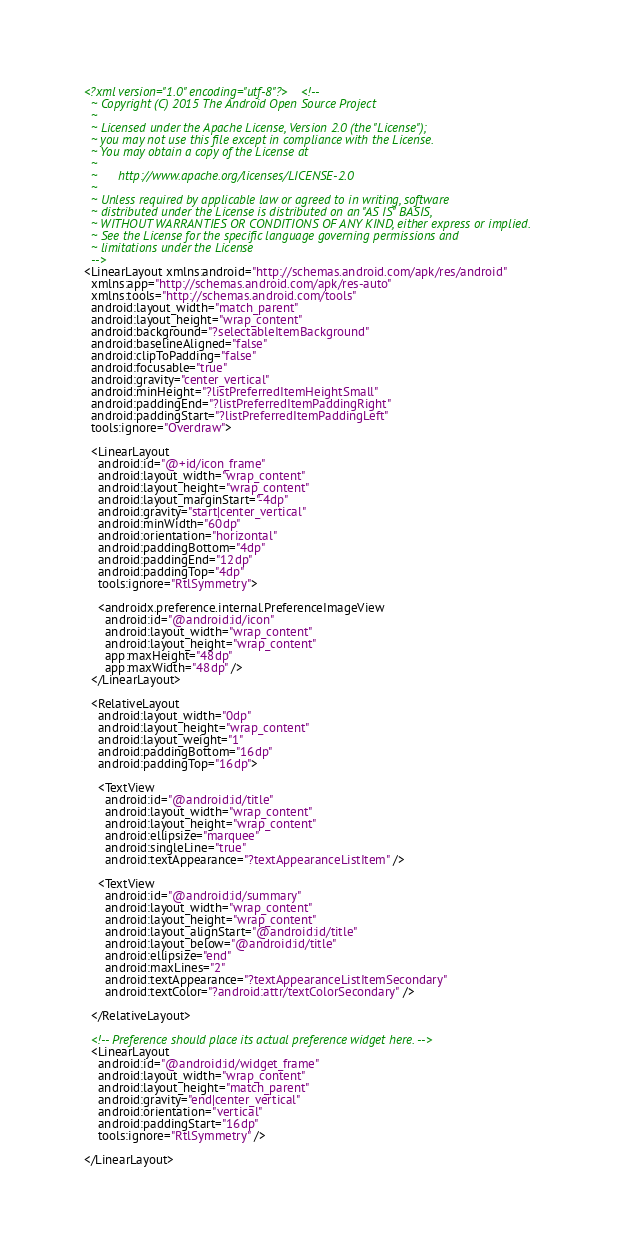<code> <loc_0><loc_0><loc_500><loc_500><_XML_><?xml version="1.0" encoding="utf-8"?><!--
  ~ Copyright (C) 2015 The Android Open Source Project
  ~
  ~ Licensed under the Apache License, Version 2.0 (the "License");
  ~ you may not use this file except in compliance with the License.
  ~ You may obtain a copy of the License at
  ~
  ~      http://www.apache.org/licenses/LICENSE-2.0
  ~
  ~ Unless required by applicable law or agreed to in writing, software
  ~ distributed under the License is distributed on an "AS IS" BASIS,
  ~ WITHOUT WARRANTIES OR CONDITIONS OF ANY KIND, either express or implied.
  ~ See the License for the specific language governing permissions and
  ~ limitations under the License
  -->
<LinearLayout xmlns:android="http://schemas.android.com/apk/res/android"
  xmlns:app="http://schemas.android.com/apk/res-auto"
  xmlns:tools="http://schemas.android.com/tools"
  android:layout_width="match_parent"
  android:layout_height="wrap_content"
  android:background="?selectableItemBackground"
  android:baselineAligned="false"
  android:clipToPadding="false"
  android:focusable="true"
  android:gravity="center_vertical"
  android:minHeight="?listPreferredItemHeightSmall"
  android:paddingEnd="?listPreferredItemPaddingRight"
  android:paddingStart="?listPreferredItemPaddingLeft"
  tools:ignore="Overdraw">

  <LinearLayout
    android:id="@+id/icon_frame"
    android:layout_width="wrap_content"
    android:layout_height="wrap_content"
    android:layout_marginStart="-4dp"
    android:gravity="start|center_vertical"
    android:minWidth="60dp"
    android:orientation="horizontal"
    android:paddingBottom="4dp"
    android:paddingEnd="12dp"
    android:paddingTop="4dp"
    tools:ignore="RtlSymmetry">

    <androidx.preference.internal.PreferenceImageView
      android:id="@android:id/icon"
      android:layout_width="wrap_content"
      android:layout_height="wrap_content"
      app:maxHeight="48dp"
      app:maxWidth="48dp" />
  </LinearLayout>

  <RelativeLayout
    android:layout_width="0dp"
    android:layout_height="wrap_content"
    android:layout_weight="1"
    android:paddingBottom="16dp"
    android:paddingTop="16dp">

    <TextView
      android:id="@android:id/title"
      android:layout_width="wrap_content"
      android:layout_height="wrap_content"
      android:ellipsize="marquee"
      android:singleLine="true"
      android:textAppearance="?textAppearanceListItem" />

    <TextView
      android:id="@android:id/summary"
      android:layout_width="wrap_content"
      android:layout_height="wrap_content"
      android:layout_alignStart="@android:id/title"
      android:layout_below="@android:id/title"
      android:ellipsize="end"
      android:maxLines="2"
      android:textAppearance="?textAppearanceListItemSecondary"
      android:textColor="?android:attr/textColorSecondary" />

  </RelativeLayout>

  <!-- Preference should place its actual preference widget here. -->
  <LinearLayout
    android:id="@android:id/widget_frame"
    android:layout_width="wrap_content"
    android:layout_height="match_parent"
    android:gravity="end|center_vertical"
    android:orientation="vertical"
    android:paddingStart="16dp"
    tools:ignore="RtlSymmetry" />

</LinearLayout>
</code> 